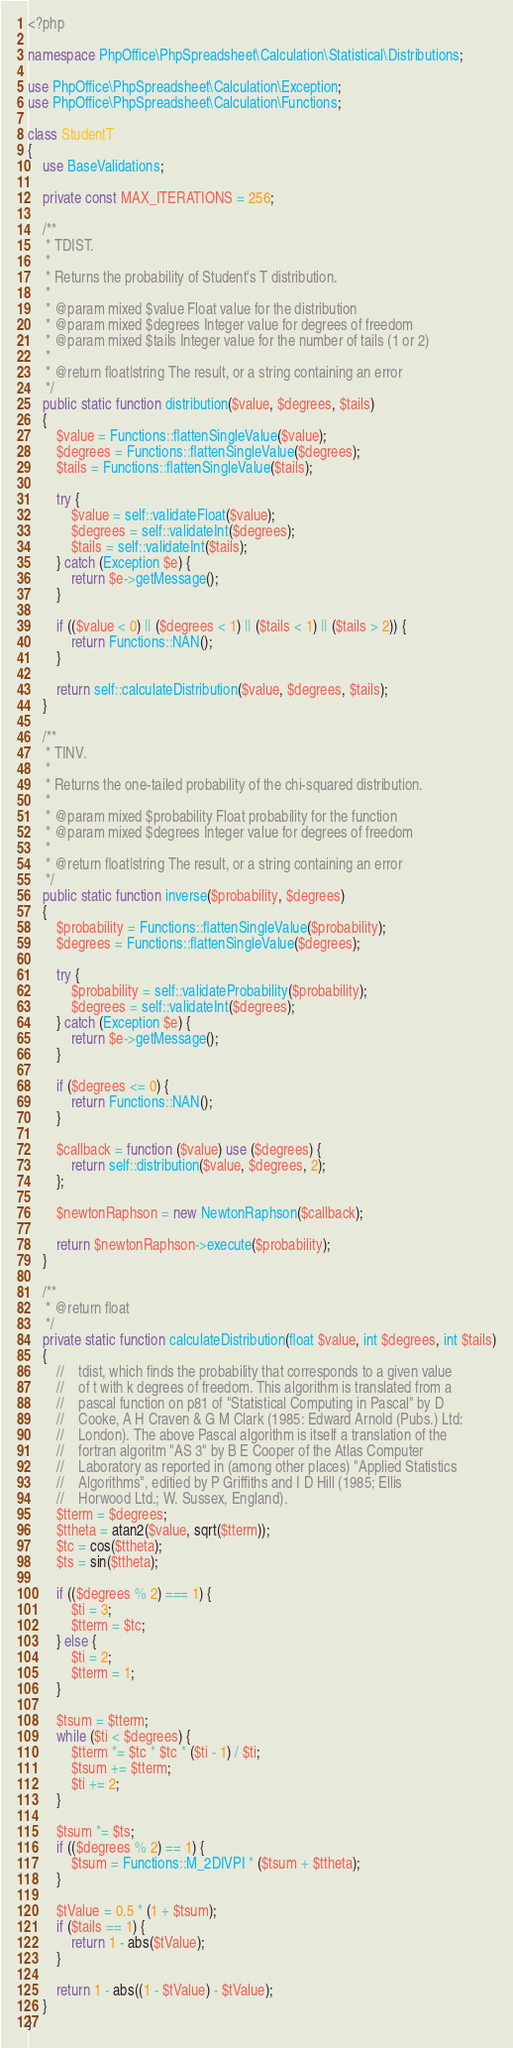Convert code to text. <code><loc_0><loc_0><loc_500><loc_500><_PHP_><?php

namespace PhpOffice\PhpSpreadsheet\Calculation\Statistical\Distributions;

use PhpOffice\PhpSpreadsheet\Calculation\Exception;
use PhpOffice\PhpSpreadsheet\Calculation\Functions;

class StudentT
{
    use BaseValidations;

    private const MAX_ITERATIONS = 256;

    /**
     * TDIST.
     *
     * Returns the probability of Student's T distribution.
     *
     * @param mixed $value Float value for the distribution
     * @param mixed $degrees Integer value for degrees of freedom
     * @param mixed $tails Integer value for the number of tails (1 or 2)
     *
     * @return float|string The result, or a string containing an error
     */
    public static function distribution($value, $degrees, $tails)
    {
        $value = Functions::flattenSingleValue($value);
        $degrees = Functions::flattenSingleValue($degrees);
        $tails = Functions::flattenSingleValue($tails);

        try {
            $value = self::validateFloat($value);
            $degrees = self::validateInt($degrees);
            $tails = self::validateInt($tails);
        } catch (Exception $e) {
            return $e->getMessage();
        }

        if (($value < 0) || ($degrees < 1) || ($tails < 1) || ($tails > 2)) {
            return Functions::NAN();
        }

        return self::calculateDistribution($value, $degrees, $tails);
    }

    /**
     * TINV.
     *
     * Returns the one-tailed probability of the chi-squared distribution.
     *
     * @param mixed $probability Float probability for the function
     * @param mixed $degrees Integer value for degrees of freedom
     *
     * @return float|string The result, or a string containing an error
     */
    public static function inverse($probability, $degrees)
    {
        $probability = Functions::flattenSingleValue($probability);
        $degrees = Functions::flattenSingleValue($degrees);

        try {
            $probability = self::validateProbability($probability);
            $degrees = self::validateInt($degrees);
        } catch (Exception $e) {
            return $e->getMessage();
        }

        if ($degrees <= 0) {
            return Functions::NAN();
        }

        $callback = function ($value) use ($degrees) {
            return self::distribution($value, $degrees, 2);
        };

        $newtonRaphson = new NewtonRaphson($callback);

        return $newtonRaphson->execute($probability);
    }

    /**
     * @return float
     */
    private static function calculateDistribution(float $value, int $degrees, int $tails)
    {
        //    tdist, which finds the probability that corresponds to a given value
        //    of t with k degrees of freedom. This algorithm is translated from a
        //    pascal function on p81 of "Statistical Computing in Pascal" by D
        //    Cooke, A H Craven & G M Clark (1985: Edward Arnold (Pubs.) Ltd:
        //    London). The above Pascal algorithm is itself a translation of the
        //    fortran algoritm "AS 3" by B E Cooper of the Atlas Computer
        //    Laboratory as reported in (among other places) "Applied Statistics
        //    Algorithms", editied by P Griffiths and I D Hill (1985; Ellis
        //    Horwood Ltd.; W. Sussex, England).
        $tterm = $degrees;
        $ttheta = atan2($value, sqrt($tterm));
        $tc = cos($ttheta);
        $ts = sin($ttheta);

        if (($degrees % 2) === 1) {
            $ti = 3;
            $tterm = $tc;
        } else {
            $ti = 2;
            $tterm = 1;
        }

        $tsum = $tterm;
        while ($ti < $degrees) {
            $tterm *= $tc * $tc * ($ti - 1) / $ti;
            $tsum += $tterm;
            $ti += 2;
        }

        $tsum *= $ts;
        if (($degrees % 2) == 1) {
            $tsum = Functions::M_2DIVPI * ($tsum + $ttheta);
        }

        $tValue = 0.5 * (1 + $tsum);
        if ($tails == 1) {
            return 1 - abs($tValue);
        }

        return 1 - abs((1 - $tValue) - $tValue);
    }
}
</code> 